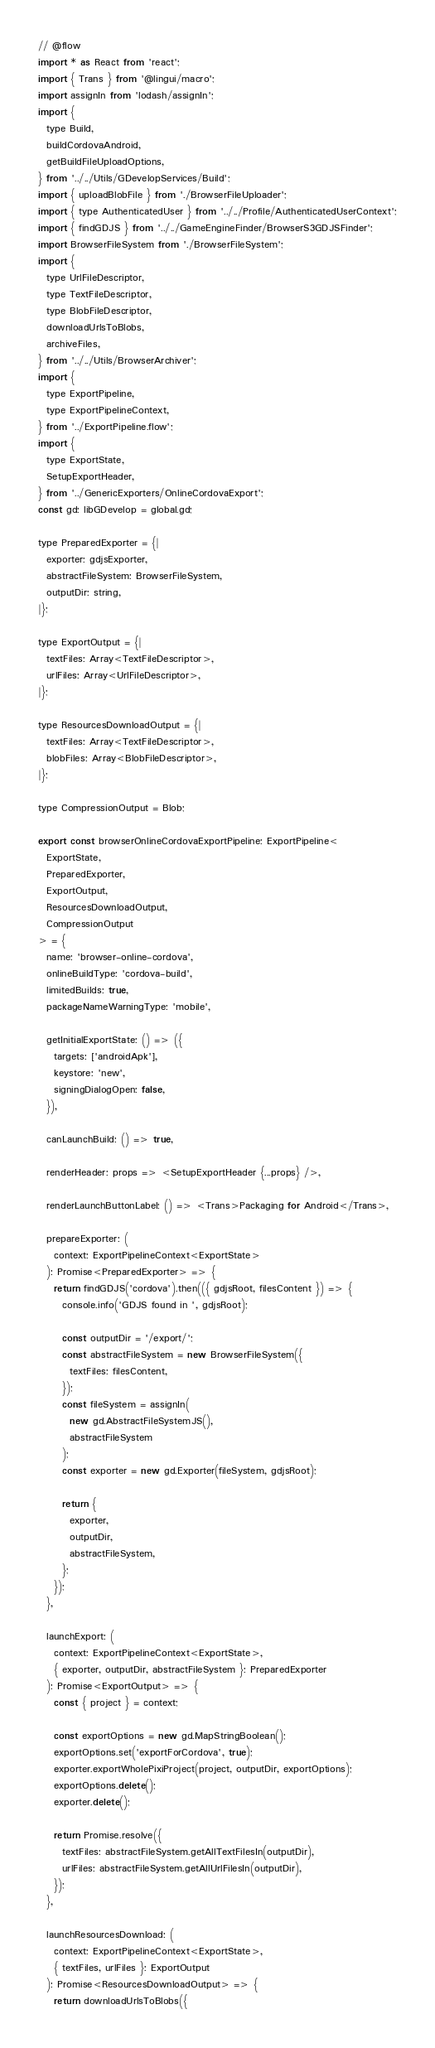Convert code to text. <code><loc_0><loc_0><loc_500><loc_500><_JavaScript_>// @flow
import * as React from 'react';
import { Trans } from '@lingui/macro';
import assignIn from 'lodash/assignIn';
import {
  type Build,
  buildCordovaAndroid,
  getBuildFileUploadOptions,
} from '../../Utils/GDevelopServices/Build';
import { uploadBlobFile } from './BrowserFileUploader';
import { type AuthenticatedUser } from '../../Profile/AuthenticatedUserContext';
import { findGDJS } from '../../GameEngineFinder/BrowserS3GDJSFinder';
import BrowserFileSystem from './BrowserFileSystem';
import {
  type UrlFileDescriptor,
  type TextFileDescriptor,
  type BlobFileDescriptor,
  downloadUrlsToBlobs,
  archiveFiles,
} from '../../Utils/BrowserArchiver';
import {
  type ExportPipeline,
  type ExportPipelineContext,
} from '../ExportPipeline.flow';
import {
  type ExportState,
  SetupExportHeader,
} from '../GenericExporters/OnlineCordovaExport';
const gd: libGDevelop = global.gd;

type PreparedExporter = {|
  exporter: gdjsExporter,
  abstractFileSystem: BrowserFileSystem,
  outputDir: string,
|};

type ExportOutput = {|
  textFiles: Array<TextFileDescriptor>,
  urlFiles: Array<UrlFileDescriptor>,
|};

type ResourcesDownloadOutput = {|
  textFiles: Array<TextFileDescriptor>,
  blobFiles: Array<BlobFileDescriptor>,
|};

type CompressionOutput = Blob;

export const browserOnlineCordovaExportPipeline: ExportPipeline<
  ExportState,
  PreparedExporter,
  ExportOutput,
  ResourcesDownloadOutput,
  CompressionOutput
> = {
  name: 'browser-online-cordova',
  onlineBuildType: 'cordova-build',
  limitedBuilds: true,
  packageNameWarningType: 'mobile',

  getInitialExportState: () => ({
    targets: ['androidApk'],
    keystore: 'new',
    signingDialogOpen: false,
  }),

  canLaunchBuild: () => true,

  renderHeader: props => <SetupExportHeader {...props} />,

  renderLaunchButtonLabel: () => <Trans>Packaging for Android</Trans>,

  prepareExporter: (
    context: ExportPipelineContext<ExportState>
  ): Promise<PreparedExporter> => {
    return findGDJS('cordova').then(({ gdjsRoot, filesContent }) => {
      console.info('GDJS found in ', gdjsRoot);

      const outputDir = '/export/';
      const abstractFileSystem = new BrowserFileSystem({
        textFiles: filesContent,
      });
      const fileSystem = assignIn(
        new gd.AbstractFileSystemJS(),
        abstractFileSystem
      );
      const exporter = new gd.Exporter(fileSystem, gdjsRoot);

      return {
        exporter,
        outputDir,
        abstractFileSystem,
      };
    });
  },

  launchExport: (
    context: ExportPipelineContext<ExportState>,
    { exporter, outputDir, abstractFileSystem }: PreparedExporter
  ): Promise<ExportOutput> => {
    const { project } = context;

    const exportOptions = new gd.MapStringBoolean();
    exportOptions.set('exportForCordova', true);
    exporter.exportWholePixiProject(project, outputDir, exportOptions);
    exportOptions.delete();
    exporter.delete();

    return Promise.resolve({
      textFiles: abstractFileSystem.getAllTextFilesIn(outputDir),
      urlFiles: abstractFileSystem.getAllUrlFilesIn(outputDir),
    });
  },

  launchResourcesDownload: (
    context: ExportPipelineContext<ExportState>,
    { textFiles, urlFiles }: ExportOutput
  ): Promise<ResourcesDownloadOutput> => {
    return downloadUrlsToBlobs({</code> 